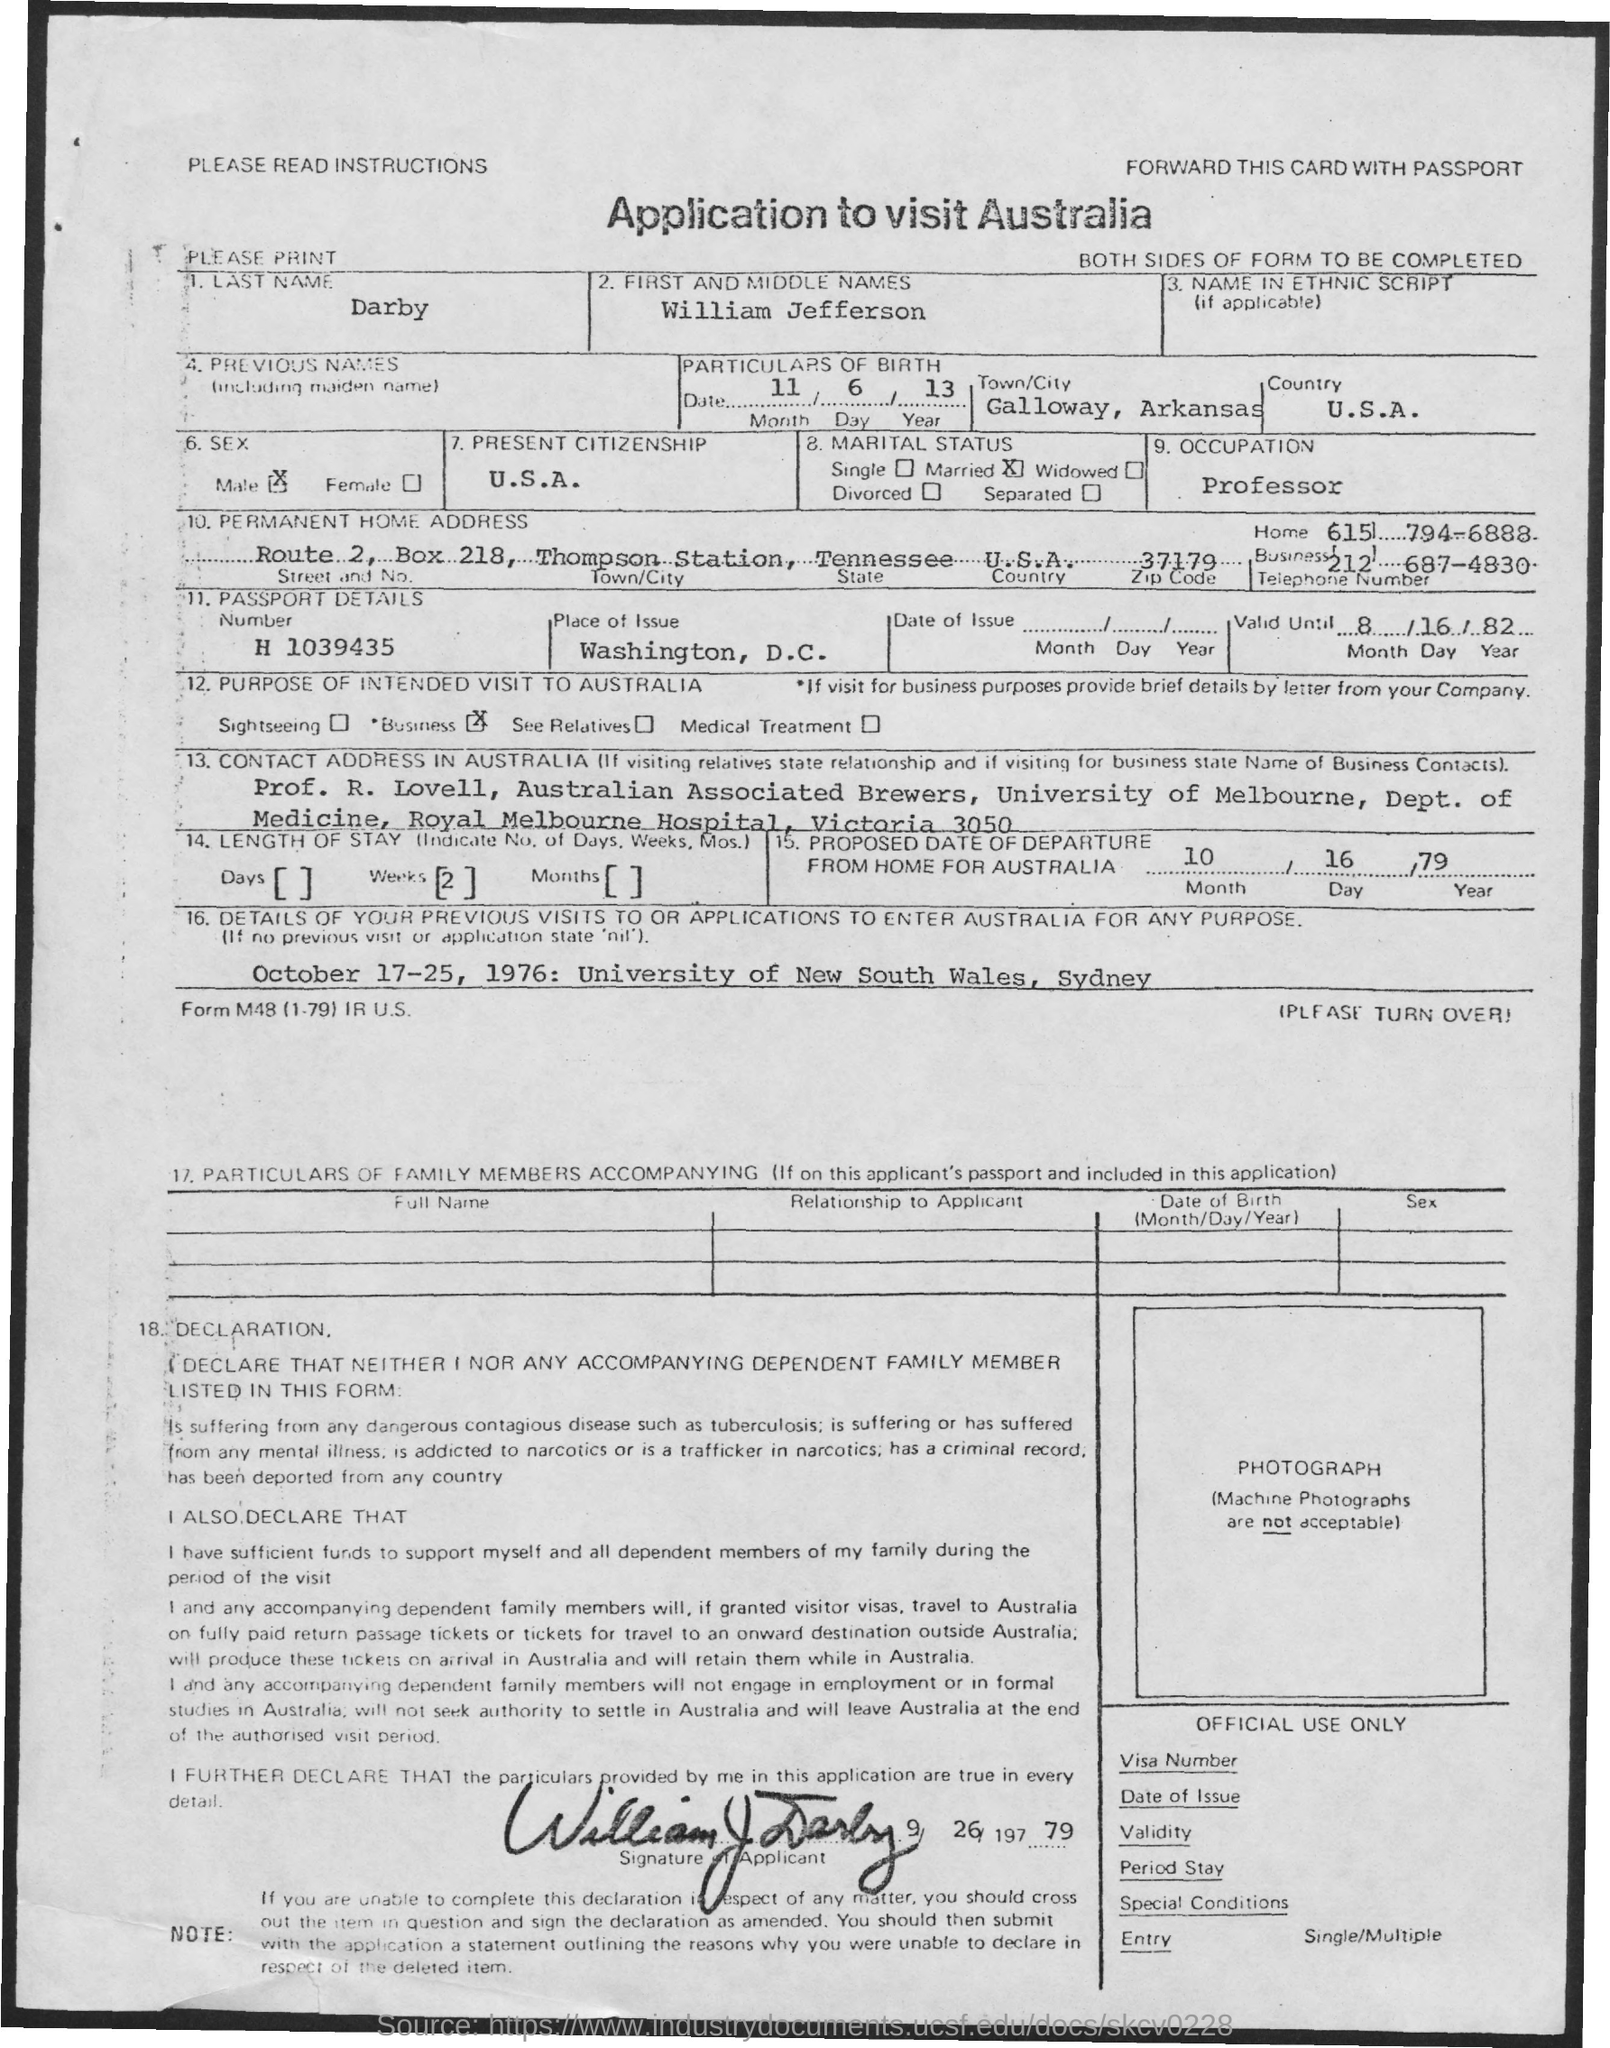Identify some key points in this picture. The applicant, William, is a professor. The given document pertains to an application to visit Australia. 